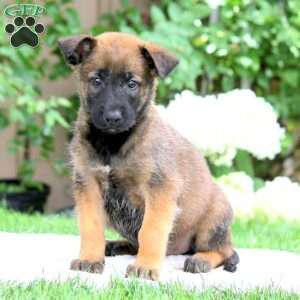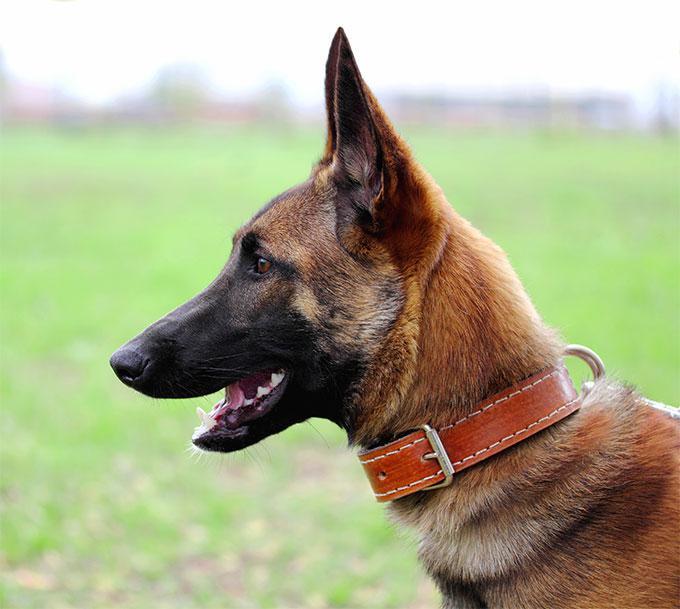The first image is the image on the left, the second image is the image on the right. For the images shown, is this caption "One of the dogs is wearing a black collar." true? Answer yes or no. No. 